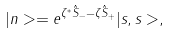<formula> <loc_0><loc_0><loc_500><loc_500>| { n } > = e ^ { \zeta ^ { * } \hat { S } _ { - } - \zeta \hat { S } _ { + } } | s , s > ,</formula> 